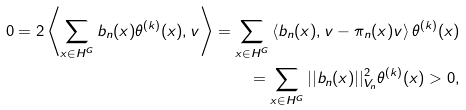Convert formula to latex. <formula><loc_0><loc_0><loc_500><loc_500>0 = 2 \left \langle \sum _ { x \in H ^ { G } } b _ { n } ( x ) \theta ^ { ( k ) } ( x ) , v \right \rangle = \sum _ { x \in H ^ { G } } \left \langle b _ { n } ( x ) , v - \pi _ { n } ( x ) v \right \rangle \theta ^ { ( k ) } ( x ) \\ = \sum _ { x \in H ^ { G } } | | b _ { n } ( x ) | | ^ { 2 } _ { V _ { n } } \theta ^ { ( k ) } ( x ) > 0 ,</formula> 